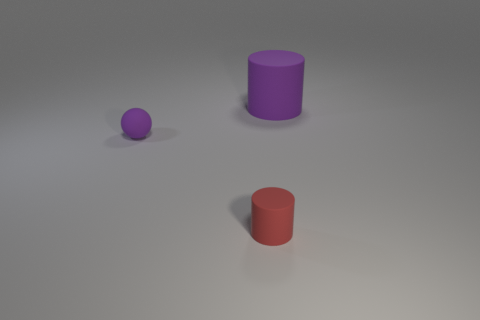Add 2 tiny red objects. How many objects exist? 5 Subtract all spheres. How many objects are left? 2 Add 3 red cylinders. How many red cylinders exist? 4 Subtract 0 red cubes. How many objects are left? 3 Subtract all red balls. Subtract all big things. How many objects are left? 2 Add 1 spheres. How many spheres are left? 2 